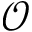Convert formula to latex. <formula><loc_0><loc_0><loc_500><loc_500>\mathcal { O }</formula> 